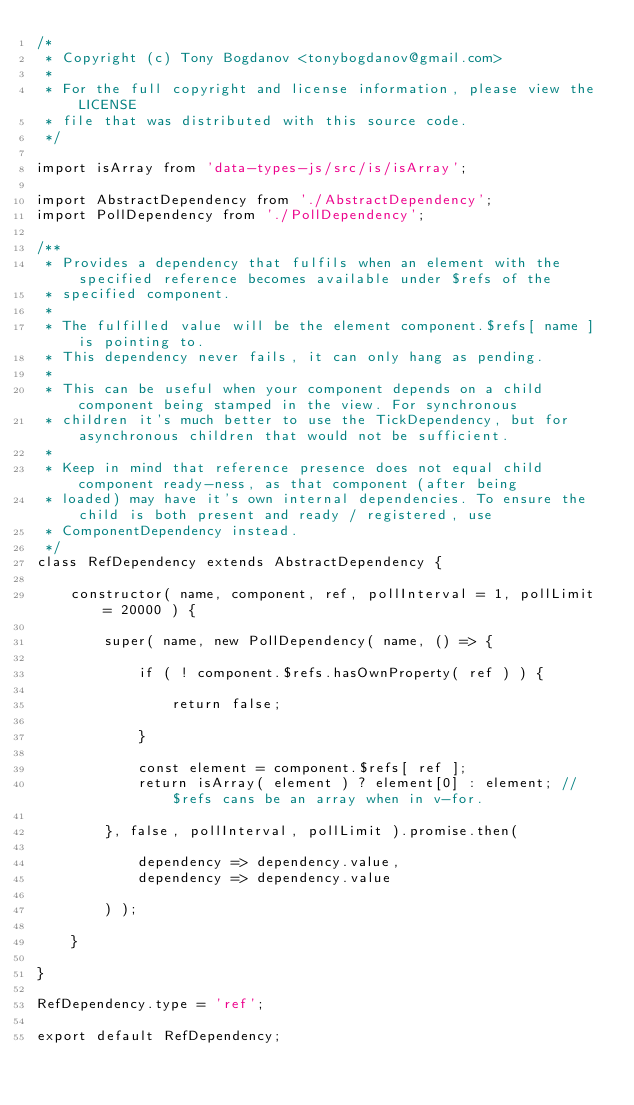<code> <loc_0><loc_0><loc_500><loc_500><_JavaScript_>/*
 * Copyright (c) Tony Bogdanov <tonybogdanov@gmail.com>
 *
 * For the full copyright and license information, please view the LICENSE
 * file that was distributed with this source code.
 */

import isArray from 'data-types-js/src/is/isArray';

import AbstractDependency from './AbstractDependency';
import PollDependency from './PollDependency';

/**
 * Provides a dependency that fulfils when an element with the specified reference becomes available under $refs of the
 * specified component.
 *
 * The fulfilled value will be the element component.$refs[ name ] is pointing to.
 * This dependency never fails, it can only hang as pending.
 *
 * This can be useful when your component depends on a child component being stamped in the view. For synchronous
 * children it's much better to use the TickDependency, but for asynchronous children that would not be sufficient.
 *
 * Keep in mind that reference presence does not equal child component ready-ness, as that component (after being
 * loaded) may have it's own internal dependencies. To ensure the child is both present and ready / registered, use
 * ComponentDependency instead.
 */
class RefDependency extends AbstractDependency {

    constructor( name, component, ref, pollInterval = 1, pollLimit = 20000 ) {

        super( name, new PollDependency( name, () => {

            if ( ! component.$refs.hasOwnProperty( ref ) ) {

                return false;

            }

            const element = component.$refs[ ref ];
            return isArray( element ) ? element[0] : element; // $refs cans be an array when in v-for.

        }, false, pollInterval, pollLimit ).promise.then(

            dependency => dependency.value,
            dependency => dependency.value

        ) );

    }

}

RefDependency.type = 'ref';

export default RefDependency;
</code> 